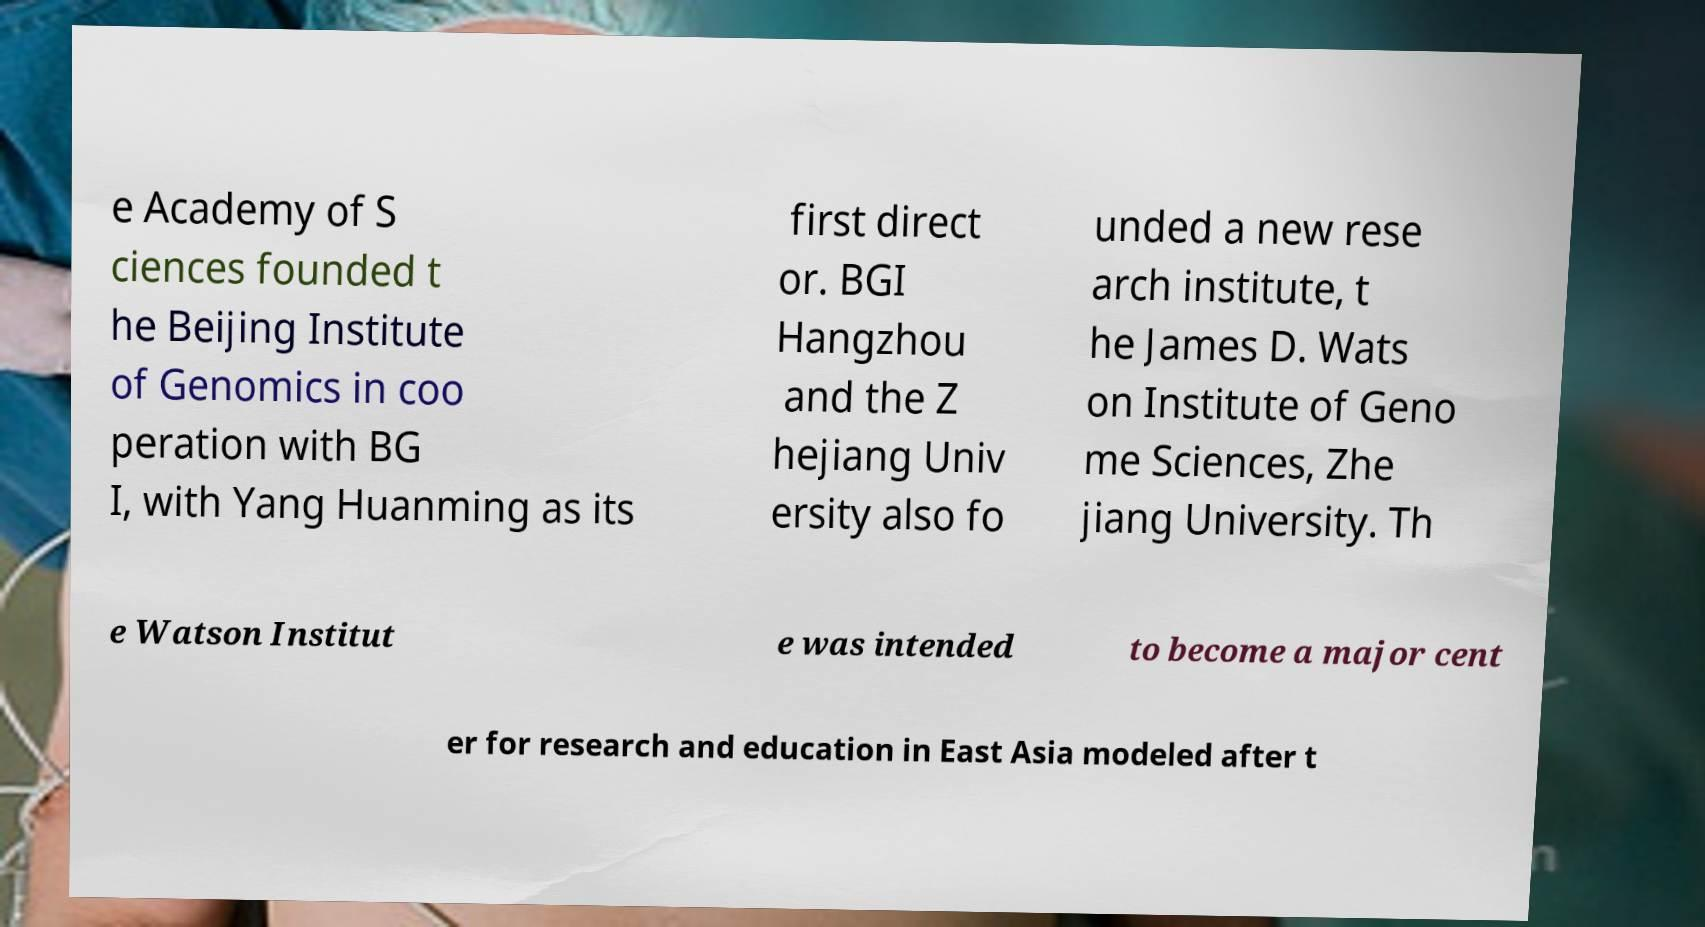Could you assist in decoding the text presented in this image and type it out clearly? e Academy of S ciences founded t he Beijing Institute of Genomics in coo peration with BG I, with Yang Huanming as its first direct or. BGI Hangzhou and the Z hejiang Univ ersity also fo unded a new rese arch institute, t he James D. Wats on Institute of Geno me Sciences, Zhe jiang University. Th e Watson Institut e was intended to become a major cent er for research and education in East Asia modeled after t 